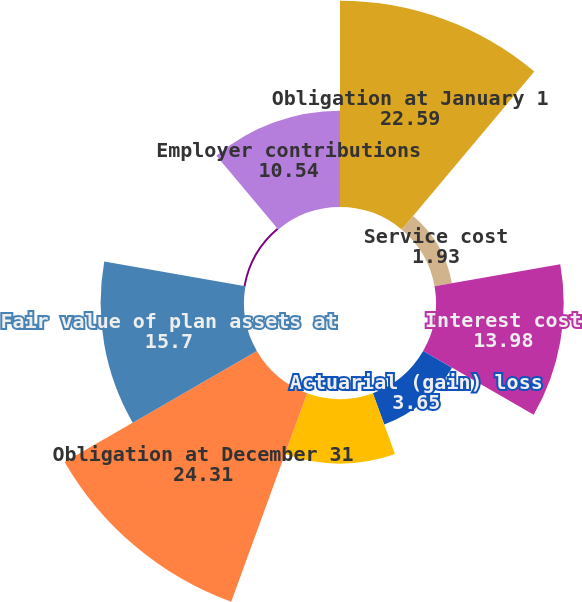Convert chart. <chart><loc_0><loc_0><loc_500><loc_500><pie_chart><fcel>Obligation at January 1<fcel>Service cost<fcel>Interest cost<fcel>Actuarial (gain) loss<fcel>Benefit payments<fcel>Obligation at December 31<fcel>Fair value of plan assets at<fcel>Actual return on plan assets<fcel>Employer contributions<nl><fcel>22.59%<fcel>1.93%<fcel>13.98%<fcel>3.65%<fcel>7.09%<fcel>24.31%<fcel>15.7%<fcel>0.21%<fcel>10.54%<nl></chart> 